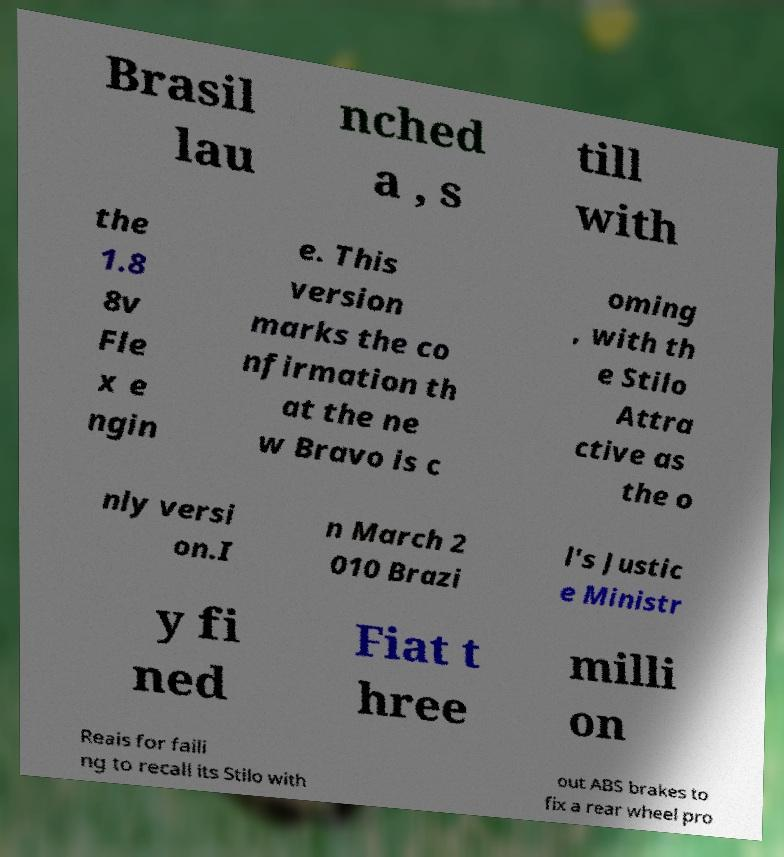Could you extract and type out the text from this image? Brasil lau nched a , s till with the 1.8 8v Fle x e ngin e. This version marks the co nfirmation th at the ne w Bravo is c oming , with th e Stilo Attra ctive as the o nly versi on.I n March 2 010 Brazi l's Justic e Ministr y fi ned Fiat t hree milli on Reais for faili ng to recall its Stilo with out ABS brakes to fix a rear wheel pro 